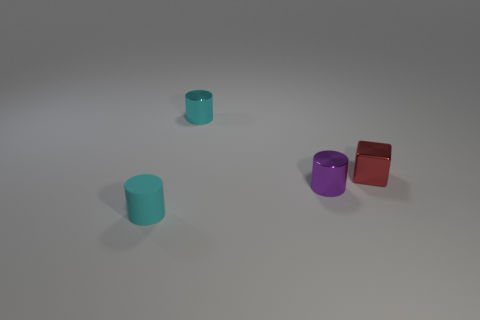How many cyan rubber cylinders are behind the purple metal cylinder that is in front of the tiny cylinder behind the small block?
Offer a terse response. 0. There is a object in front of the small purple cylinder that is right of the small cyan metallic cylinder; what shape is it?
Make the answer very short. Cylinder. There is a cyan rubber object that is the same shape as the tiny cyan metal thing; what size is it?
Your answer should be compact. Small. What color is the shiny object in front of the small red shiny object?
Your answer should be compact. Purple. What is the material of the cylinder on the right side of the cyan thing that is behind the cyan cylinder in front of the red metal block?
Offer a very short reply. Metal. The tiny matte thing that is the same shape as the tiny purple shiny object is what color?
Offer a very short reply. Cyan. How many small objects have the same color as the tiny rubber cylinder?
Your answer should be compact. 1. Do the red metal block and the purple thing have the same size?
Make the answer very short. Yes. What is the material of the tiny red object?
Make the answer very short. Metal. The small block that is made of the same material as the small purple cylinder is what color?
Give a very brief answer. Red. 